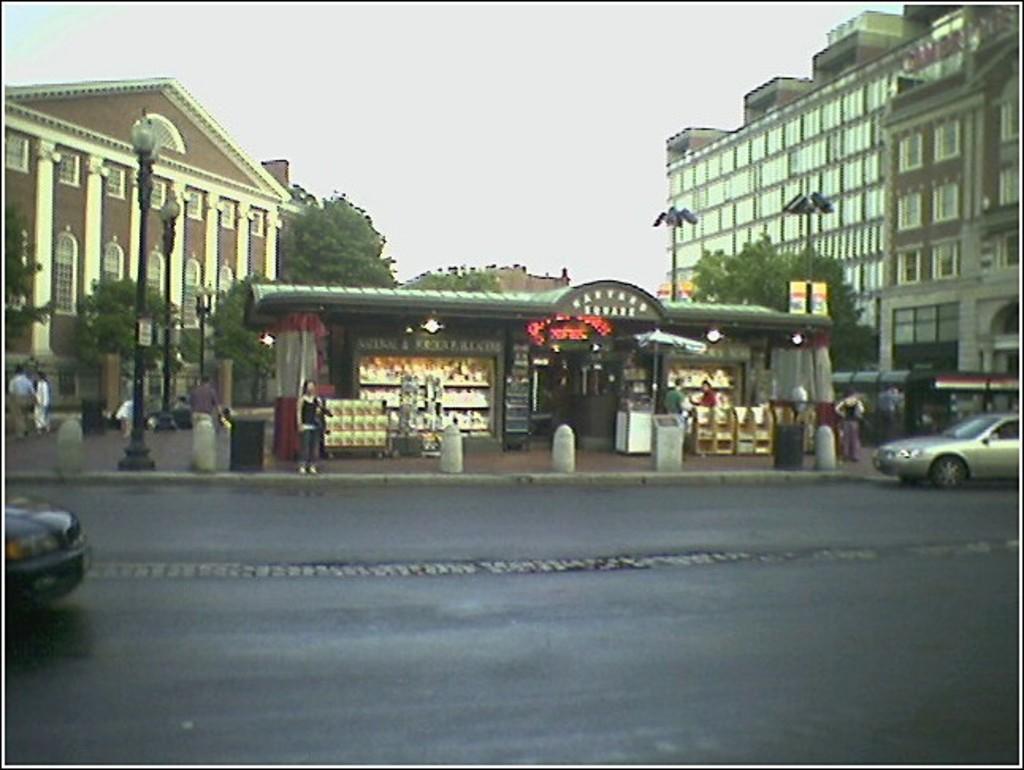Can you describe this image briefly? This picture is clicked outside the city. Here, we see cars moving on the road. Beside that, we see people standing on sideways and we even see street lights. Behind them, we see ships and there are many trees and buildings in the background. At the top of the picture, we see the sky and at the bottom of the picture, we see the road. 